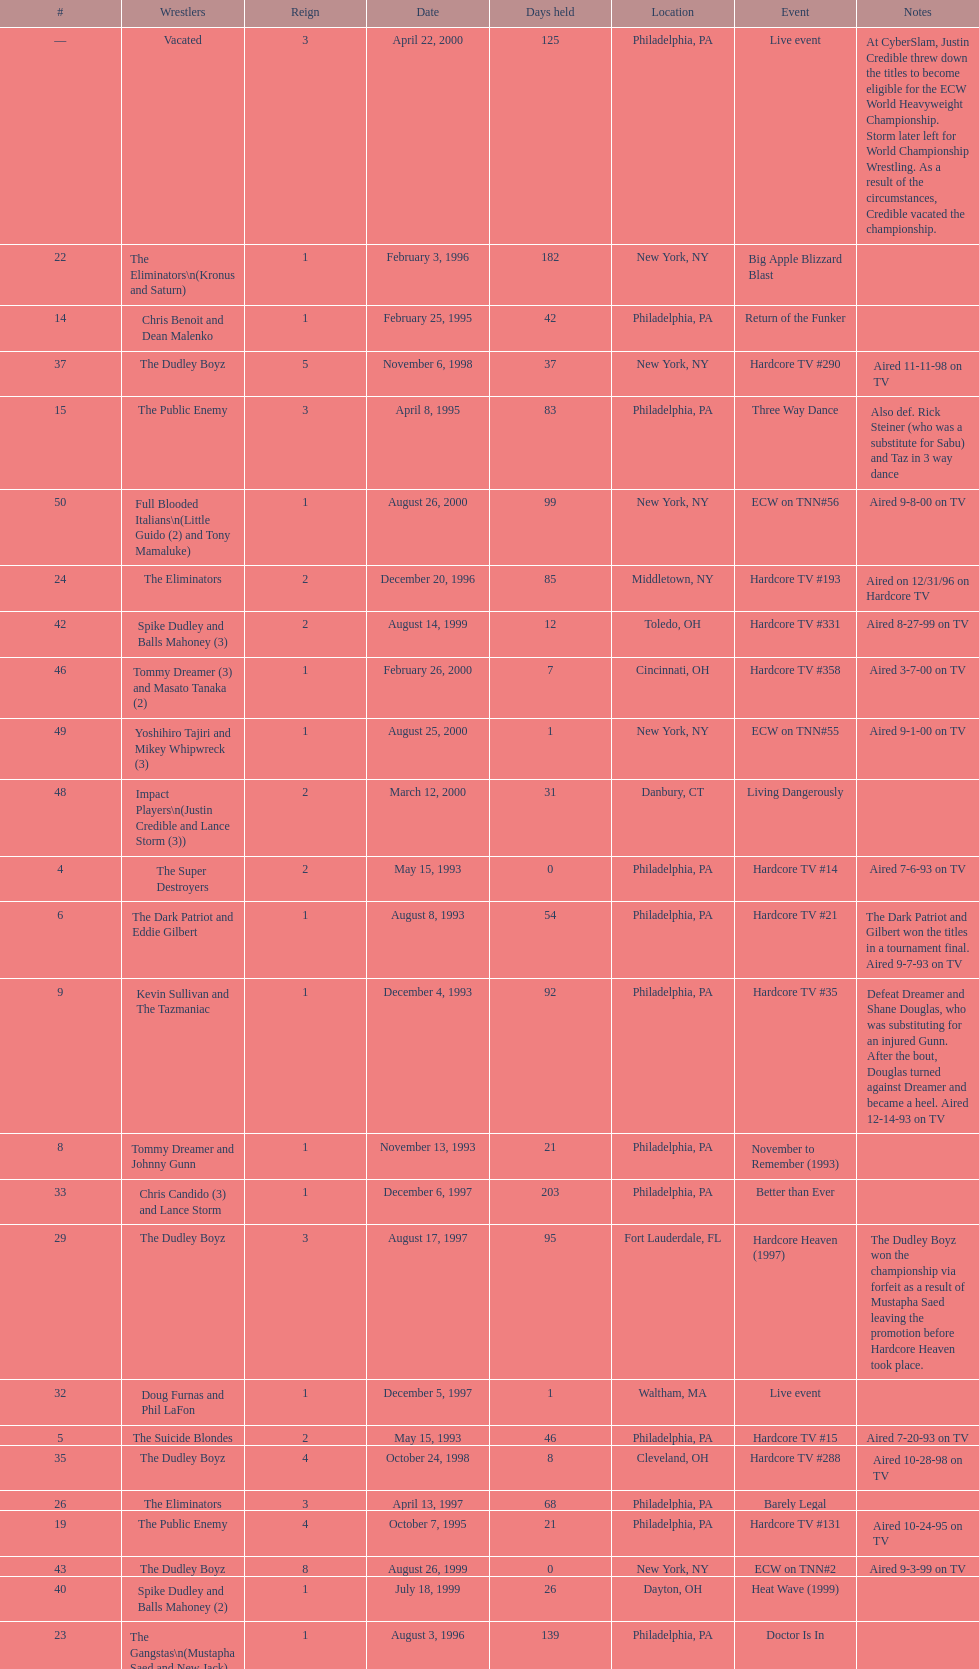What is the total days held on # 1st? 283. 